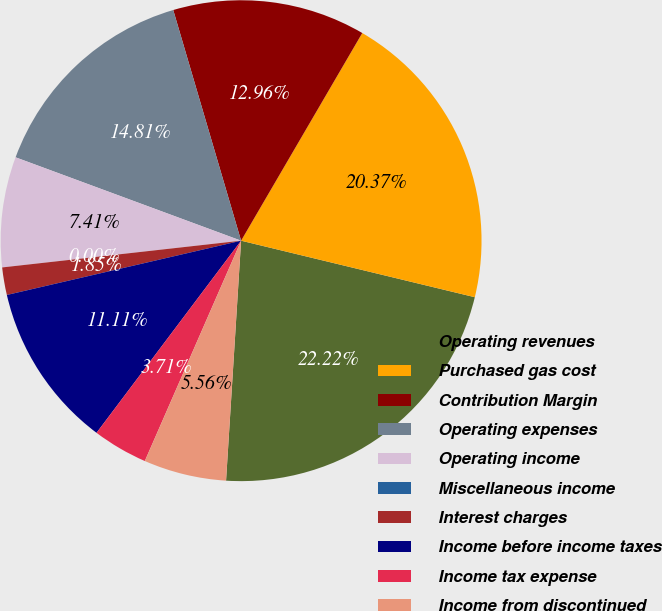Convert chart to OTSL. <chart><loc_0><loc_0><loc_500><loc_500><pie_chart><fcel>Operating revenues<fcel>Purchased gas cost<fcel>Contribution Margin<fcel>Operating expenses<fcel>Operating income<fcel>Miscellaneous income<fcel>Interest charges<fcel>Income before income taxes<fcel>Income tax expense<fcel>Income from discontinued<nl><fcel>22.22%<fcel>20.37%<fcel>12.96%<fcel>14.81%<fcel>7.41%<fcel>0.0%<fcel>1.85%<fcel>11.11%<fcel>3.71%<fcel>5.56%<nl></chart> 